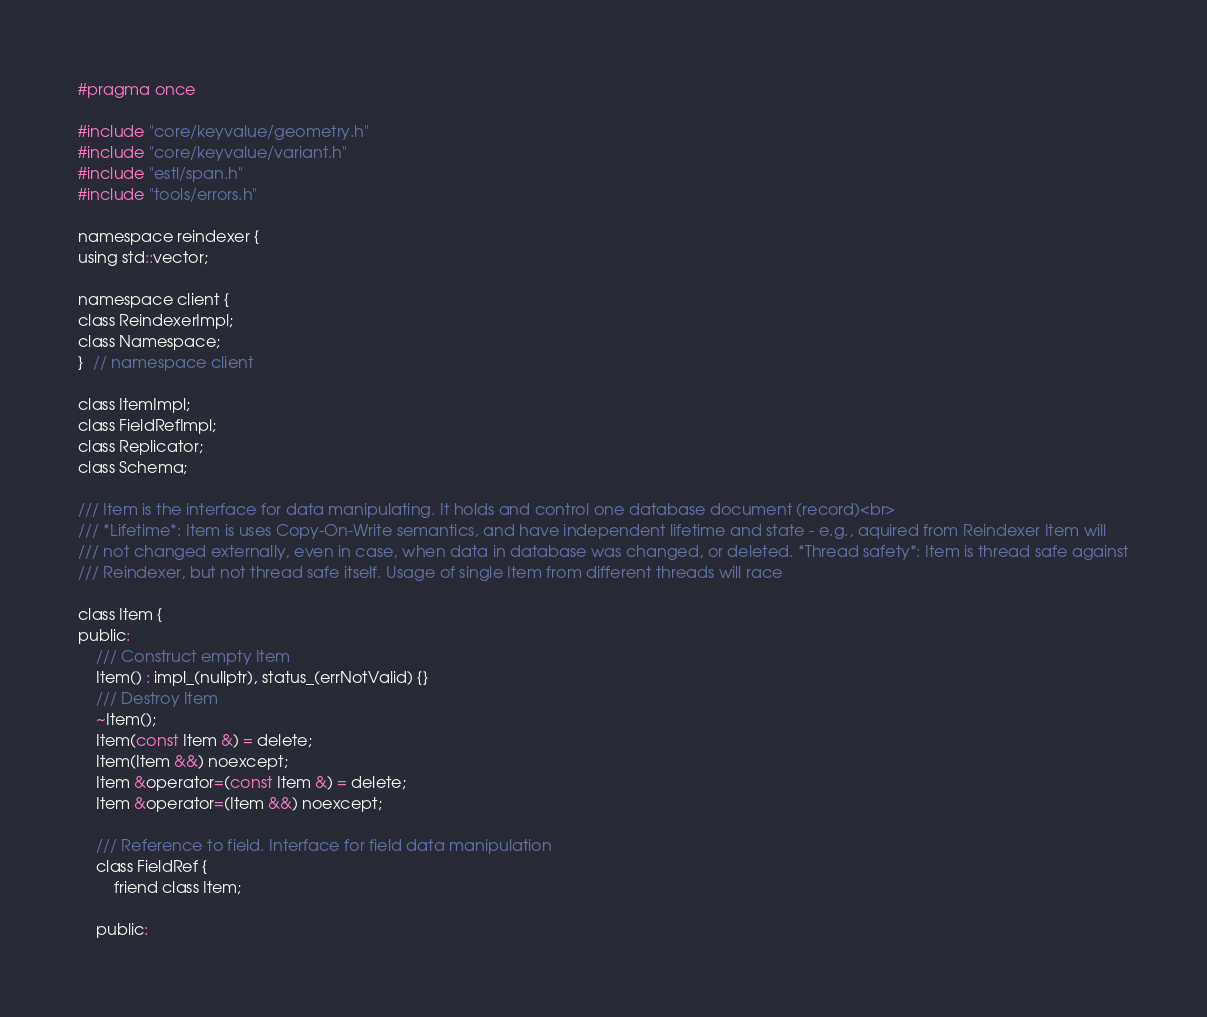Convert code to text. <code><loc_0><loc_0><loc_500><loc_500><_C_>#pragma once

#include "core/keyvalue/geometry.h"
#include "core/keyvalue/variant.h"
#include "estl/span.h"
#include "tools/errors.h"

namespace reindexer {
using std::vector;

namespace client {
class ReindexerImpl;
class Namespace;
}  // namespace client

class ItemImpl;
class FieldRefImpl;
class Replicator;
class Schema;

/// Item is the interface for data manipulating. It holds and control one database document (record)<br>
/// *Lifetime*: Item is uses Copy-On-Write semantics, and have independent lifetime and state - e.g., aquired from Reindexer Item will
/// not changed externally, even in case, when data in database was changed, or deleted. *Thread safety*: Item is thread safe against
/// Reindexer, but not thread safe itself. Usage of single Item from different threads will race

class Item {
public:
	/// Construct empty Item
	Item() : impl_(nullptr), status_(errNotValid) {}
	/// Destroy Item
	~Item();
	Item(const Item &) = delete;
	Item(Item &&) noexcept;
	Item &operator=(const Item &) = delete;
	Item &operator=(Item &&) noexcept;

	/// Reference to field. Interface for field data manipulation
	class FieldRef {
		friend class Item;

	public:</code> 